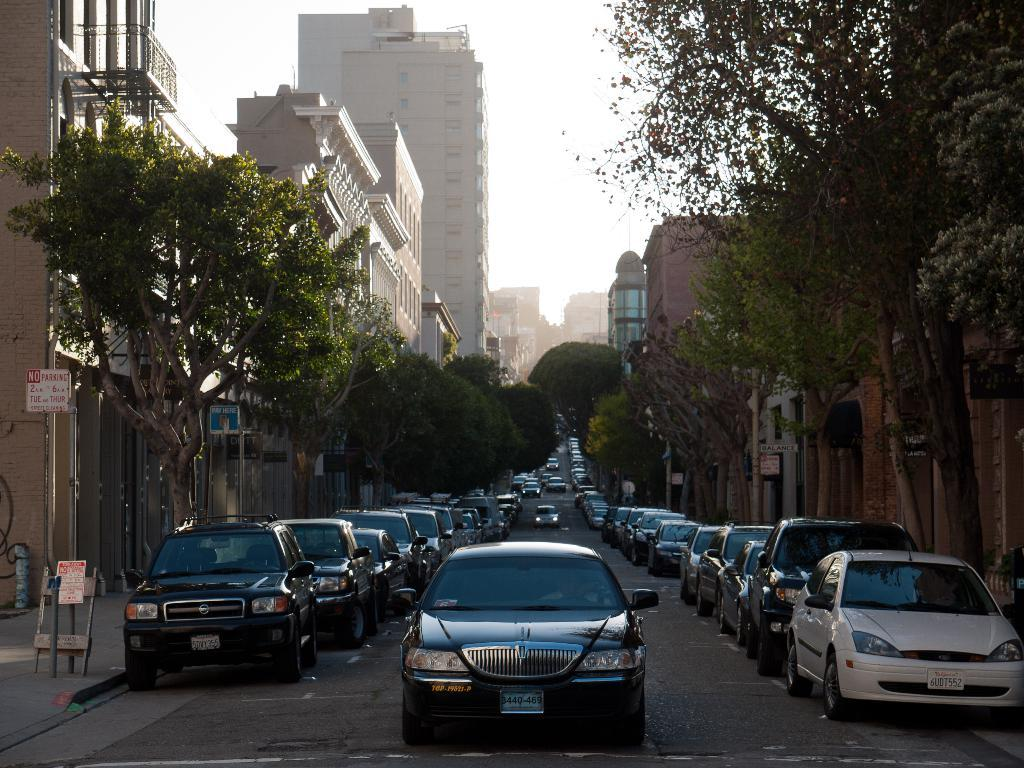What type of structures can be seen in the image? There are buildings in the image. What else can be seen in the image besides buildings? There are trees, cars on the road, sign boards, and sky visible in the background of the image. Where are the sign boards located in the image? The sign boards are on the left side of the image. What type of plastic is being used by the grandmother in the image? There is no grandmother or plastic present in the image. How does the temper of the cars on the road affect the traffic in the image? The image does not provide information about the temper of the cars or how it might affect traffic. 